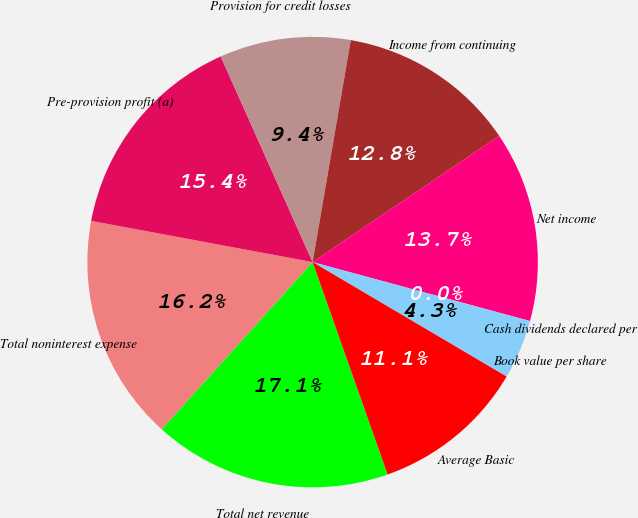Convert chart to OTSL. <chart><loc_0><loc_0><loc_500><loc_500><pie_chart><fcel>Total net revenue<fcel>Total noninterest expense<fcel>Pre-provision profit (a)<fcel>Provision for credit losses<fcel>Income from continuing<fcel>Net income<fcel>Cash dividends declared per<fcel>Book value per share<fcel>Average Basic<nl><fcel>17.09%<fcel>16.24%<fcel>15.38%<fcel>9.4%<fcel>12.82%<fcel>13.68%<fcel>0.0%<fcel>4.27%<fcel>11.11%<nl></chart> 